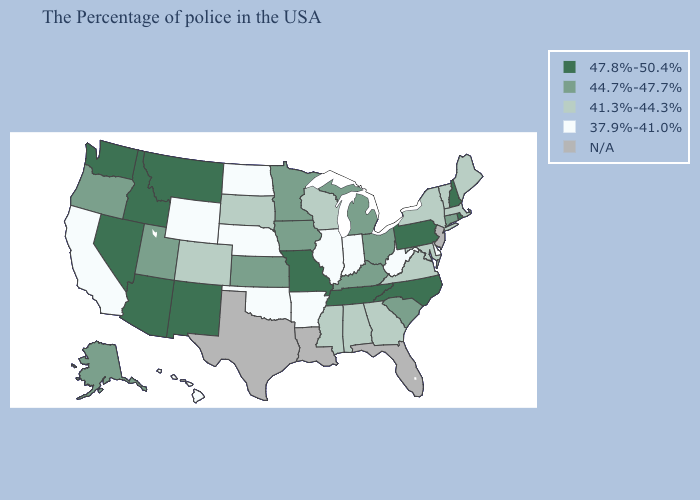Is the legend a continuous bar?
Short answer required. No. Name the states that have a value in the range 44.7%-47.7%?
Keep it brief. Connecticut, South Carolina, Ohio, Michigan, Kentucky, Minnesota, Iowa, Kansas, Utah, Oregon, Alaska. Name the states that have a value in the range 41.3%-44.3%?
Answer briefly. Maine, Massachusetts, Vermont, New York, Maryland, Virginia, Georgia, Alabama, Wisconsin, Mississippi, South Dakota, Colorado. What is the value of Maryland?
Be succinct. 41.3%-44.3%. What is the value of California?
Give a very brief answer. 37.9%-41.0%. Which states have the lowest value in the USA?
Concise answer only. Delaware, West Virginia, Indiana, Illinois, Arkansas, Nebraska, Oklahoma, North Dakota, Wyoming, California, Hawaii. Does New York have the lowest value in the Northeast?
Concise answer only. Yes. Name the states that have a value in the range 41.3%-44.3%?
Write a very short answer. Maine, Massachusetts, Vermont, New York, Maryland, Virginia, Georgia, Alabama, Wisconsin, Mississippi, South Dakota, Colorado. What is the value of Hawaii?
Answer briefly. 37.9%-41.0%. Among the states that border Connecticut , which have the lowest value?
Answer briefly. Massachusetts, New York. Among the states that border California , does Oregon have the lowest value?
Keep it brief. Yes. Does Hawaii have the highest value in the West?
Concise answer only. No. Does North Carolina have the lowest value in the South?
Keep it brief. No. What is the highest value in the West ?
Concise answer only. 47.8%-50.4%. 